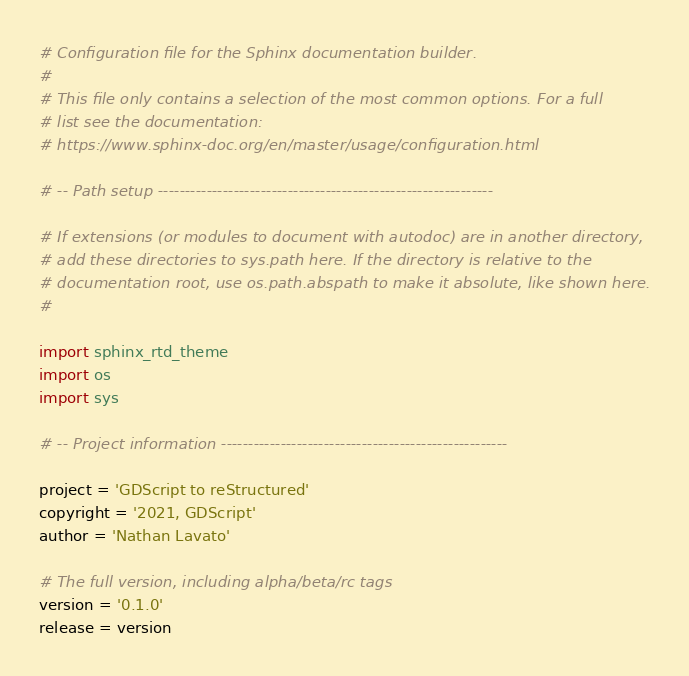Convert code to text. <code><loc_0><loc_0><loc_500><loc_500><_Python_># Configuration file for the Sphinx documentation builder.
#
# This file only contains a selection of the most common options. For a full
# list see the documentation:
# https://www.sphinx-doc.org/en/master/usage/configuration.html

# -- Path setup --------------------------------------------------------------

# If extensions (or modules to document with autodoc) are in another directory,
# add these directories to sys.path here. If the directory is relative to the
# documentation root, use os.path.abspath to make it absolute, like shown here.
#

import sphinx_rtd_theme
import os
import sys

# -- Project information -----------------------------------------------------

project = 'GDScript to reStructured'
copyright = '2021, GDScript'
author = 'Nathan Lavato'

# The full version, including alpha/beta/rc tags
version = '0.1.0'
release = version
</code> 